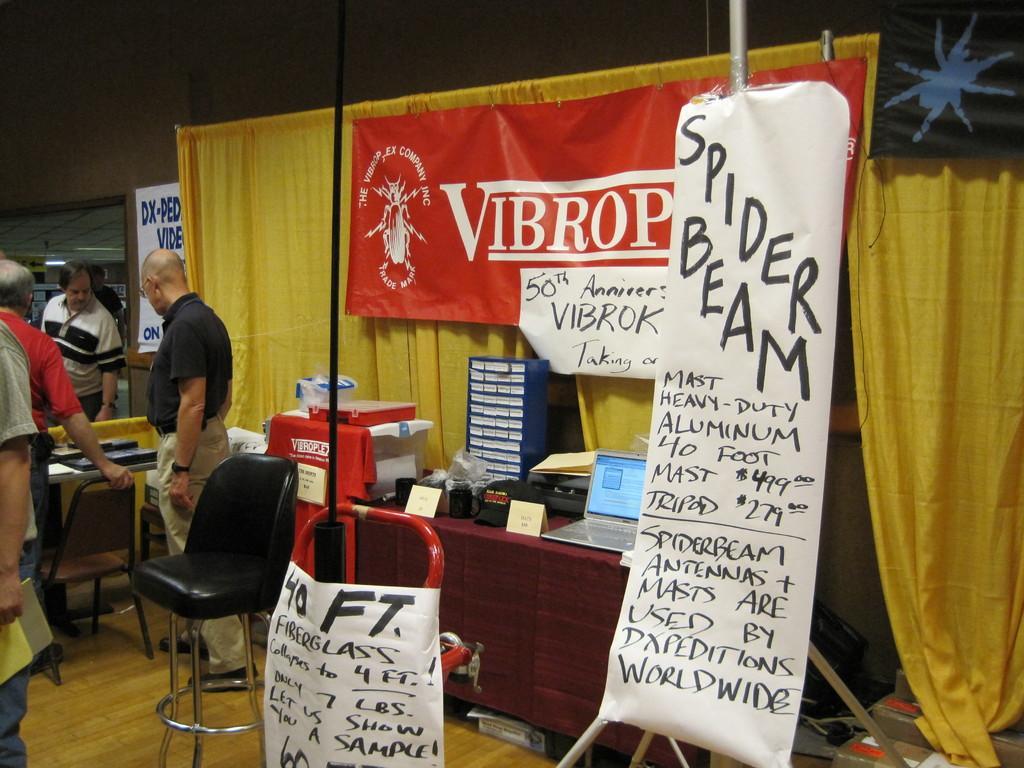Could you give a brief overview of what you see in this image? In this image we can see a banner, chair, laptop, curtains and few persons standing on the floor. 